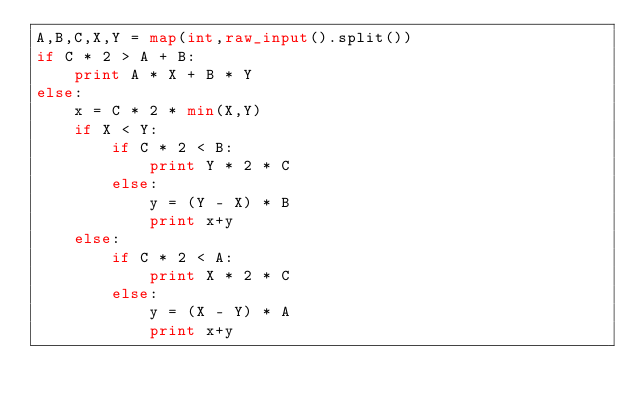<code> <loc_0><loc_0><loc_500><loc_500><_Python_>A,B,C,X,Y = map(int,raw_input().split())
if C * 2 > A + B:
	print A * X + B * Y
else:
	x = C * 2 * min(X,Y)
	if X < Y:
		if C * 2 < B:
			print Y * 2 * C
		else:
			y = (Y - X) * B
			print x+y
	else:
		if C * 2 < A:
			print X * 2 * C
		else:
			y = (X - Y) * A
			print x+y</code> 